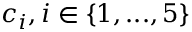<formula> <loc_0><loc_0><loc_500><loc_500>c _ { i } , i \in \{ 1 , \dots , 5 \}</formula> 